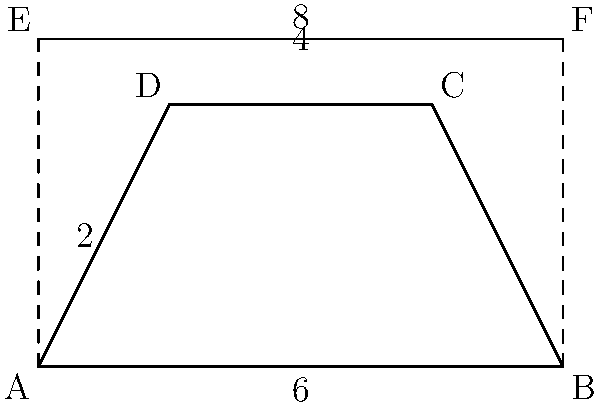As a member of the altar guild, you are tasked with creating a new altar cloth for a trapezoidal altar table. The table measures 6 units at the base, 4 units at the top, and has a height of 4 units. The rectangular cloth should hang down 1 unit on all sides. What are the dimensions of the rectangular altar cloth needed to perfectly cover this altar table? Let's approach this step-by-step:

1) First, we need to determine the width of the altar cloth:
   - The base of the trapezoid is 6 units
   - The cloth should hang down 1 unit on each side
   - So, the width of the cloth = 6 + 1 + 1 = 8 units

2) Next, let's calculate the length of the altar cloth:
   - The height of the trapezoid is 4 units
   - The cloth should hang down 1 unit on the top and bottom
   - So, the length of the cloth = 4 + 1 + 1 = 6 units

3) Therefore, the dimensions of the rectangular altar cloth are 8 units wide by 6 units long.

4) We can verify this by checking:
   - The cloth will cover the 6-unit base and hang 1 unit on each side (6 + 1 + 1 = 8)
   - It will cover the 4-unit height and hang 1 unit on top and bottom (4 + 1 + 1 = 6)

Thus, a rectangular cloth of 8 units by 6 units will perfectly cover the trapezoidal altar table with the desired overhang.
Answer: $8 \times 6$ units 